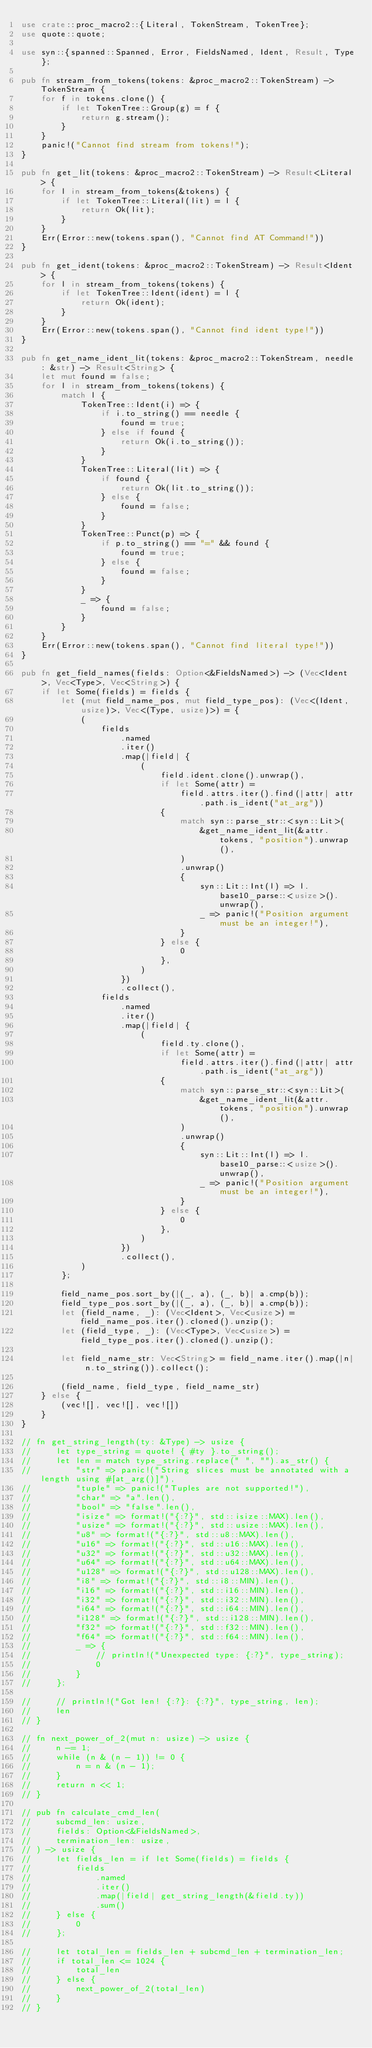Convert code to text. <code><loc_0><loc_0><loc_500><loc_500><_Rust_>use crate::proc_macro2::{Literal, TokenStream, TokenTree};
use quote::quote;

use syn::{spanned::Spanned, Error, FieldsNamed, Ident, Result, Type};

pub fn stream_from_tokens(tokens: &proc_macro2::TokenStream) -> TokenStream {
    for f in tokens.clone() {
        if let TokenTree::Group(g) = f {
            return g.stream();
        }
    }
    panic!("Cannot find stream from tokens!");
}

pub fn get_lit(tokens: &proc_macro2::TokenStream) -> Result<Literal> {
    for l in stream_from_tokens(&tokens) {
        if let TokenTree::Literal(lit) = l {
            return Ok(lit);
        }
    }
    Err(Error::new(tokens.span(), "Cannot find AT Command!"))
}

pub fn get_ident(tokens: &proc_macro2::TokenStream) -> Result<Ident> {
    for l in stream_from_tokens(tokens) {
        if let TokenTree::Ident(ident) = l {
            return Ok(ident);
        }
    }
    Err(Error::new(tokens.span(), "Cannot find ident type!"))
}

pub fn get_name_ident_lit(tokens: &proc_macro2::TokenStream, needle: &str) -> Result<String> {
    let mut found = false;
    for l in stream_from_tokens(tokens) {
        match l {
            TokenTree::Ident(i) => {
                if i.to_string() == needle {
                    found = true;
                } else if found {
                    return Ok(i.to_string());
                }
            }
            TokenTree::Literal(lit) => {
                if found {
                    return Ok(lit.to_string());
                } else {
                    found = false;
                }
            }
            TokenTree::Punct(p) => {
                if p.to_string() == "=" && found {
                    found = true;
                } else {
                    found = false;
                }
            }
            _ => {
                found = false;
            }
        }
    }
    Err(Error::new(tokens.span(), "Cannot find literal type!"))
}

pub fn get_field_names(fields: Option<&FieldsNamed>) -> (Vec<Ident>, Vec<Type>, Vec<String>) {
    if let Some(fields) = fields {
        let (mut field_name_pos, mut field_type_pos): (Vec<(Ident, usize)>, Vec<(Type, usize)>) = {
            (
                fields
                    .named
                    .iter()
                    .map(|field| {
                        (
                            field.ident.clone().unwrap(),
                            if let Some(attr) =
                                field.attrs.iter().find(|attr| attr.path.is_ident("at_arg"))
                            {
                                match syn::parse_str::<syn::Lit>(
                                    &get_name_ident_lit(&attr.tokens, "position").unwrap(),
                                )
                                .unwrap()
                                {
                                    syn::Lit::Int(l) => l.base10_parse::<usize>().unwrap(),
                                    _ => panic!("Position argument must be an integer!"),
                                }
                            } else {
                                0
                            },
                        )
                    })
                    .collect(),
                fields
                    .named
                    .iter()
                    .map(|field| {
                        (
                            field.ty.clone(),
                            if let Some(attr) =
                                field.attrs.iter().find(|attr| attr.path.is_ident("at_arg"))
                            {
                                match syn::parse_str::<syn::Lit>(
                                    &get_name_ident_lit(&attr.tokens, "position").unwrap(),
                                )
                                .unwrap()
                                {
                                    syn::Lit::Int(l) => l.base10_parse::<usize>().unwrap(),
                                    _ => panic!("Position argument must be an integer!"),
                                }
                            } else {
                                0
                            },
                        )
                    })
                    .collect(),
            )
        };

        field_name_pos.sort_by(|(_, a), (_, b)| a.cmp(b));
        field_type_pos.sort_by(|(_, a), (_, b)| a.cmp(b));
        let (field_name, _): (Vec<Ident>, Vec<usize>) = field_name_pos.iter().cloned().unzip();
        let (field_type, _): (Vec<Type>, Vec<usize>) = field_type_pos.iter().cloned().unzip();

        let field_name_str: Vec<String> = field_name.iter().map(|n| n.to_string()).collect();

        (field_name, field_type, field_name_str)
    } else {
        (vec![], vec![], vec![])
    }
}

// fn get_string_length(ty: &Type) -> usize {
//     let type_string = quote! { #ty }.to_string();
//     let len = match type_string.replace(" ", "").as_str() {
//         "str" => panic!("String slices must be annotated with a length using #[at_arg()]"),
//         "tuple" => panic!("Tuples are not supported!"),
//         "char" => "a".len(),
//         "bool" => "false".len(),
//         "isize" => format!("{:?}", std::isize::MAX).len(),
//         "usize" => format!("{:?}", std::usize::MAX).len(),
//         "u8" => format!("{:?}", std::u8::MAX).len(),
//         "u16" => format!("{:?}", std::u16::MAX).len(),
//         "u32" => format!("{:?}", std::u32::MAX).len(),
//         "u64" => format!("{:?}", std::u64::MAX).len(),
//         "u128" => format!("{:?}", std::u128::MAX).len(),
//         "i8" => format!("{:?}", std::i8::MIN).len(),
//         "i16" => format!("{:?}", std::i16::MIN).len(),
//         "i32" => format!("{:?}", std::i32::MIN).len(),
//         "i64" => format!("{:?}", std::i64::MIN).len(),
//         "i128" => format!("{:?}", std::i128::MIN).len(),
//         "f32" => format!("{:?}", std::f32::MIN).len(),
//         "f64" => format!("{:?}", std::f64::MIN).len(),
//         _ => {
//             // println!("Unexpected type: {:?}", type_string);
//             0
//         }
//     };

//     // println!("Got len! {:?}: {:?}", type_string, len);
//     len
// }

// fn next_power_of_2(mut n: usize) -> usize {
//     n -= 1;
//     while (n & (n - 1)) != 0 {
//         n = n & (n - 1);
//     }
//     return n << 1;
// }

// pub fn calculate_cmd_len(
//     subcmd_len: usize,
//     fields: Option<&FieldsNamed>,
//     termination_len: usize,
// ) -> usize {
//     let fields_len = if let Some(fields) = fields {
//         fields
//             .named
//             .iter()
//             .map(|field| get_string_length(&field.ty))
//             .sum()
//     } else {
//         0
//     };

//     let total_len = fields_len + subcmd_len + termination_len;
//     if total_len <= 1024 {
//         total_len
//     } else {
//         next_power_of_2(total_len)
//     }
// }
</code> 